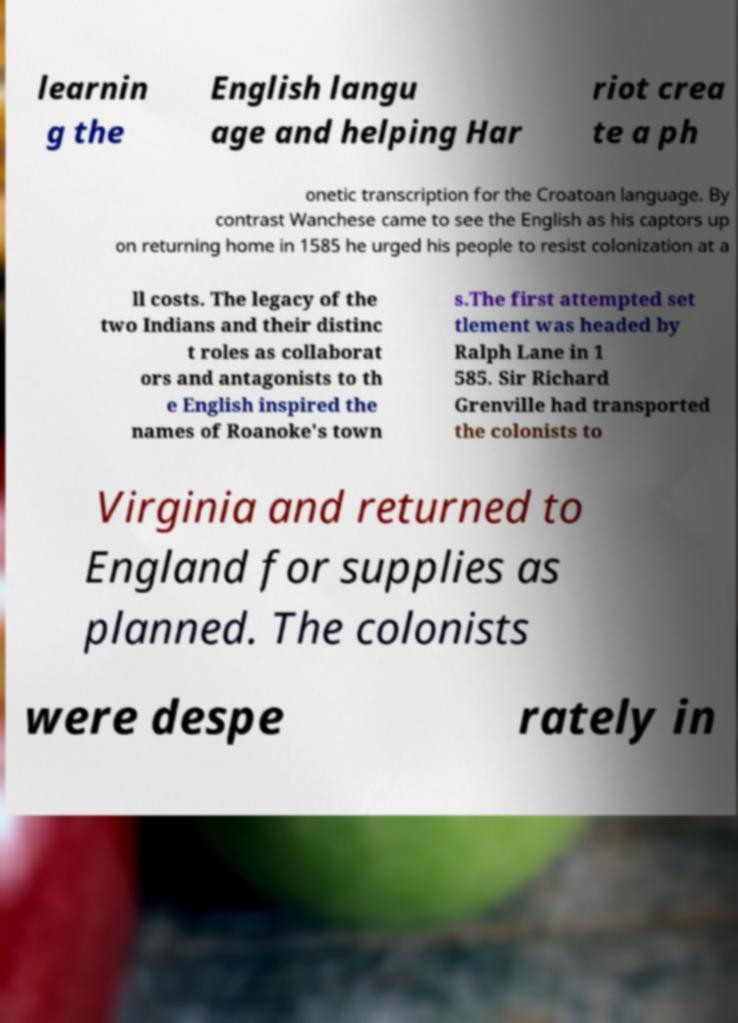Could you assist in decoding the text presented in this image and type it out clearly? learnin g the English langu age and helping Har riot crea te a ph onetic transcription for the Croatoan language. By contrast Wanchese came to see the English as his captors up on returning home in 1585 he urged his people to resist colonization at a ll costs. The legacy of the two Indians and their distinc t roles as collaborat ors and antagonists to th e English inspired the names of Roanoke's town s.The first attempted set tlement was headed by Ralph Lane in 1 585. Sir Richard Grenville had transported the colonists to Virginia and returned to England for supplies as planned. The colonists were despe rately in 